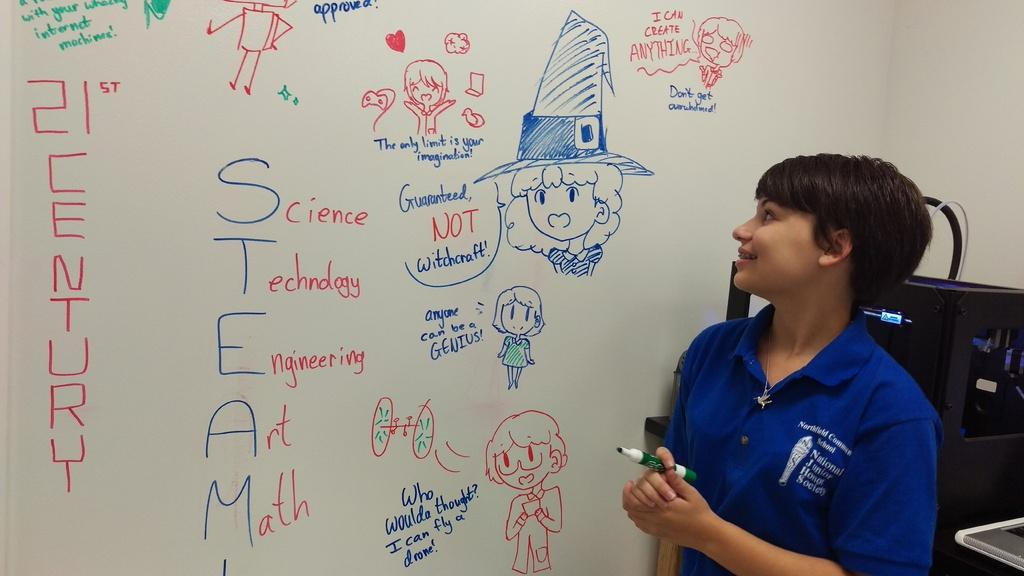Provide a one-sentence caption for the provided image. A teacher stands next to the board where cartoon pictures surround the word STEAM and each letter has a word next to it. 